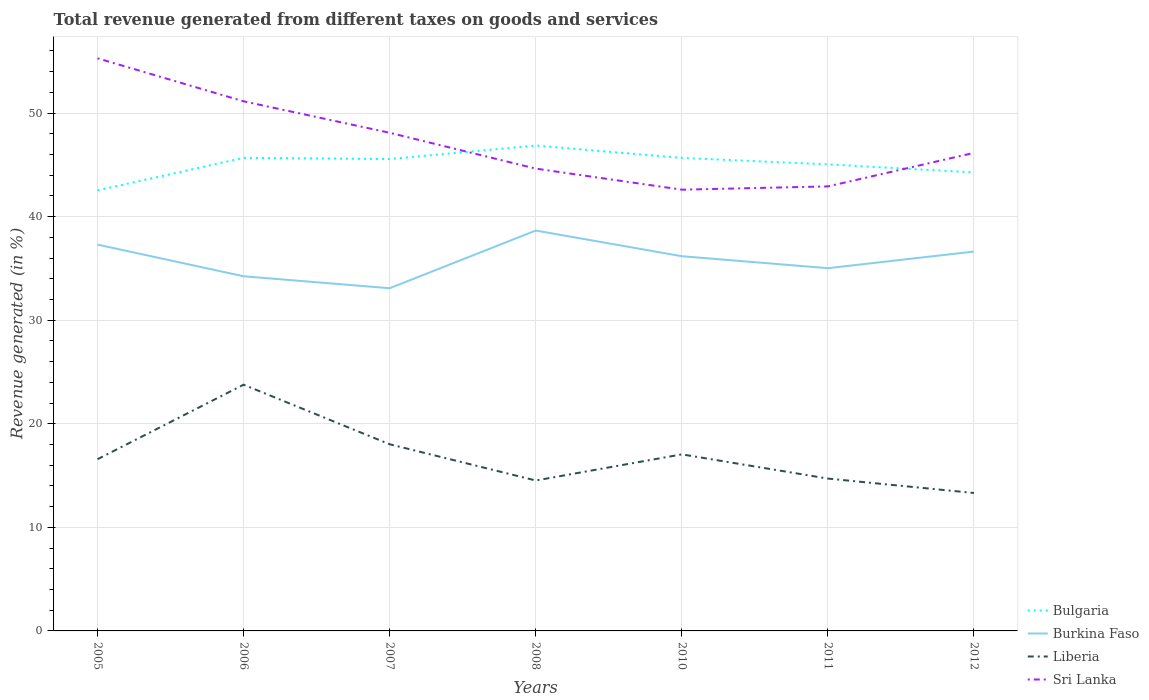How many different coloured lines are there?
Provide a short and direct response. 4. Does the line corresponding to Sri Lanka intersect with the line corresponding to Bulgaria?
Provide a short and direct response. Yes. Is the number of lines equal to the number of legend labels?
Give a very brief answer. Yes. Across all years, what is the maximum total revenue generated in Burkina Faso?
Provide a succinct answer. 33.08. In which year was the total revenue generated in Burkina Faso maximum?
Your response must be concise. 2007. What is the total total revenue generated in Sri Lanka in the graph?
Your response must be concise. -1.52. What is the difference between the highest and the second highest total revenue generated in Liberia?
Offer a terse response. 10.45. What is the difference between two consecutive major ticks on the Y-axis?
Your answer should be very brief. 10. Are the values on the major ticks of Y-axis written in scientific E-notation?
Your answer should be compact. No. Does the graph contain any zero values?
Give a very brief answer. No. Does the graph contain grids?
Offer a very short reply. Yes. How many legend labels are there?
Your response must be concise. 4. How are the legend labels stacked?
Your answer should be compact. Vertical. What is the title of the graph?
Make the answer very short. Total revenue generated from different taxes on goods and services. Does "Iraq" appear as one of the legend labels in the graph?
Offer a terse response. No. What is the label or title of the Y-axis?
Your answer should be very brief. Revenue generated (in %). What is the Revenue generated (in %) of Bulgaria in 2005?
Give a very brief answer. 42.54. What is the Revenue generated (in %) of Burkina Faso in 2005?
Ensure brevity in your answer.  37.3. What is the Revenue generated (in %) of Liberia in 2005?
Provide a succinct answer. 16.58. What is the Revenue generated (in %) in Sri Lanka in 2005?
Keep it short and to the point. 55.28. What is the Revenue generated (in %) in Bulgaria in 2006?
Your answer should be very brief. 45.67. What is the Revenue generated (in %) of Burkina Faso in 2006?
Offer a very short reply. 34.24. What is the Revenue generated (in %) in Liberia in 2006?
Your response must be concise. 23.77. What is the Revenue generated (in %) in Sri Lanka in 2006?
Make the answer very short. 51.13. What is the Revenue generated (in %) of Bulgaria in 2007?
Ensure brevity in your answer.  45.56. What is the Revenue generated (in %) in Burkina Faso in 2007?
Provide a succinct answer. 33.08. What is the Revenue generated (in %) of Liberia in 2007?
Give a very brief answer. 18.02. What is the Revenue generated (in %) of Sri Lanka in 2007?
Your answer should be very brief. 48.09. What is the Revenue generated (in %) in Bulgaria in 2008?
Make the answer very short. 46.86. What is the Revenue generated (in %) in Burkina Faso in 2008?
Provide a succinct answer. 38.66. What is the Revenue generated (in %) in Liberia in 2008?
Provide a succinct answer. 14.52. What is the Revenue generated (in %) of Sri Lanka in 2008?
Keep it short and to the point. 44.63. What is the Revenue generated (in %) in Bulgaria in 2010?
Keep it short and to the point. 45.67. What is the Revenue generated (in %) of Burkina Faso in 2010?
Offer a terse response. 36.18. What is the Revenue generated (in %) in Liberia in 2010?
Offer a terse response. 17.05. What is the Revenue generated (in %) of Sri Lanka in 2010?
Your response must be concise. 42.6. What is the Revenue generated (in %) in Bulgaria in 2011?
Offer a terse response. 45.04. What is the Revenue generated (in %) in Burkina Faso in 2011?
Keep it short and to the point. 35.02. What is the Revenue generated (in %) of Liberia in 2011?
Offer a terse response. 14.71. What is the Revenue generated (in %) of Sri Lanka in 2011?
Provide a short and direct response. 42.92. What is the Revenue generated (in %) in Bulgaria in 2012?
Ensure brevity in your answer.  44.27. What is the Revenue generated (in %) in Burkina Faso in 2012?
Your response must be concise. 36.63. What is the Revenue generated (in %) of Liberia in 2012?
Offer a very short reply. 13.32. What is the Revenue generated (in %) in Sri Lanka in 2012?
Give a very brief answer. 46.15. Across all years, what is the maximum Revenue generated (in %) in Bulgaria?
Keep it short and to the point. 46.86. Across all years, what is the maximum Revenue generated (in %) of Burkina Faso?
Your answer should be compact. 38.66. Across all years, what is the maximum Revenue generated (in %) in Liberia?
Give a very brief answer. 23.77. Across all years, what is the maximum Revenue generated (in %) in Sri Lanka?
Provide a short and direct response. 55.28. Across all years, what is the minimum Revenue generated (in %) of Bulgaria?
Your answer should be compact. 42.54. Across all years, what is the minimum Revenue generated (in %) of Burkina Faso?
Ensure brevity in your answer.  33.08. Across all years, what is the minimum Revenue generated (in %) of Liberia?
Ensure brevity in your answer.  13.32. Across all years, what is the minimum Revenue generated (in %) in Sri Lanka?
Offer a terse response. 42.6. What is the total Revenue generated (in %) in Bulgaria in the graph?
Make the answer very short. 315.61. What is the total Revenue generated (in %) of Burkina Faso in the graph?
Keep it short and to the point. 251.1. What is the total Revenue generated (in %) of Liberia in the graph?
Ensure brevity in your answer.  117.96. What is the total Revenue generated (in %) of Sri Lanka in the graph?
Give a very brief answer. 330.81. What is the difference between the Revenue generated (in %) in Bulgaria in 2005 and that in 2006?
Offer a terse response. -3.14. What is the difference between the Revenue generated (in %) in Burkina Faso in 2005 and that in 2006?
Provide a succinct answer. 3.06. What is the difference between the Revenue generated (in %) of Liberia in 2005 and that in 2006?
Make the answer very short. -7.19. What is the difference between the Revenue generated (in %) of Sri Lanka in 2005 and that in 2006?
Your answer should be compact. 4.15. What is the difference between the Revenue generated (in %) in Bulgaria in 2005 and that in 2007?
Your answer should be compact. -3.02. What is the difference between the Revenue generated (in %) in Burkina Faso in 2005 and that in 2007?
Ensure brevity in your answer.  4.21. What is the difference between the Revenue generated (in %) in Liberia in 2005 and that in 2007?
Your response must be concise. -1.44. What is the difference between the Revenue generated (in %) in Sri Lanka in 2005 and that in 2007?
Offer a terse response. 7.19. What is the difference between the Revenue generated (in %) of Bulgaria in 2005 and that in 2008?
Your answer should be compact. -4.33. What is the difference between the Revenue generated (in %) in Burkina Faso in 2005 and that in 2008?
Offer a terse response. -1.36. What is the difference between the Revenue generated (in %) of Liberia in 2005 and that in 2008?
Give a very brief answer. 2.06. What is the difference between the Revenue generated (in %) in Sri Lanka in 2005 and that in 2008?
Your answer should be compact. 10.65. What is the difference between the Revenue generated (in %) in Bulgaria in 2005 and that in 2010?
Make the answer very short. -3.13. What is the difference between the Revenue generated (in %) of Burkina Faso in 2005 and that in 2010?
Provide a short and direct response. 1.12. What is the difference between the Revenue generated (in %) in Liberia in 2005 and that in 2010?
Your answer should be very brief. -0.47. What is the difference between the Revenue generated (in %) in Sri Lanka in 2005 and that in 2010?
Provide a short and direct response. 12.68. What is the difference between the Revenue generated (in %) of Bulgaria in 2005 and that in 2011?
Ensure brevity in your answer.  -2.51. What is the difference between the Revenue generated (in %) in Burkina Faso in 2005 and that in 2011?
Provide a succinct answer. 2.28. What is the difference between the Revenue generated (in %) of Liberia in 2005 and that in 2011?
Give a very brief answer. 1.87. What is the difference between the Revenue generated (in %) of Sri Lanka in 2005 and that in 2011?
Offer a very short reply. 12.37. What is the difference between the Revenue generated (in %) of Bulgaria in 2005 and that in 2012?
Your answer should be very brief. -1.74. What is the difference between the Revenue generated (in %) in Burkina Faso in 2005 and that in 2012?
Your answer should be compact. 0.67. What is the difference between the Revenue generated (in %) in Liberia in 2005 and that in 2012?
Provide a short and direct response. 3.26. What is the difference between the Revenue generated (in %) in Sri Lanka in 2005 and that in 2012?
Give a very brief answer. 9.13. What is the difference between the Revenue generated (in %) in Bulgaria in 2006 and that in 2007?
Provide a succinct answer. 0.11. What is the difference between the Revenue generated (in %) in Burkina Faso in 2006 and that in 2007?
Your answer should be very brief. 1.16. What is the difference between the Revenue generated (in %) of Liberia in 2006 and that in 2007?
Your answer should be compact. 5.75. What is the difference between the Revenue generated (in %) of Sri Lanka in 2006 and that in 2007?
Make the answer very short. 3.04. What is the difference between the Revenue generated (in %) of Bulgaria in 2006 and that in 2008?
Your response must be concise. -1.19. What is the difference between the Revenue generated (in %) of Burkina Faso in 2006 and that in 2008?
Give a very brief answer. -4.42. What is the difference between the Revenue generated (in %) in Liberia in 2006 and that in 2008?
Provide a short and direct response. 9.25. What is the difference between the Revenue generated (in %) in Sri Lanka in 2006 and that in 2008?
Offer a terse response. 6.5. What is the difference between the Revenue generated (in %) in Bulgaria in 2006 and that in 2010?
Your response must be concise. 0.01. What is the difference between the Revenue generated (in %) in Burkina Faso in 2006 and that in 2010?
Give a very brief answer. -1.94. What is the difference between the Revenue generated (in %) in Liberia in 2006 and that in 2010?
Give a very brief answer. 6.73. What is the difference between the Revenue generated (in %) of Sri Lanka in 2006 and that in 2010?
Ensure brevity in your answer.  8.53. What is the difference between the Revenue generated (in %) in Bulgaria in 2006 and that in 2011?
Make the answer very short. 0.63. What is the difference between the Revenue generated (in %) in Burkina Faso in 2006 and that in 2011?
Your answer should be compact. -0.78. What is the difference between the Revenue generated (in %) of Liberia in 2006 and that in 2011?
Offer a very short reply. 9.06. What is the difference between the Revenue generated (in %) of Sri Lanka in 2006 and that in 2011?
Keep it short and to the point. 8.22. What is the difference between the Revenue generated (in %) of Bulgaria in 2006 and that in 2012?
Your answer should be very brief. 1.4. What is the difference between the Revenue generated (in %) of Burkina Faso in 2006 and that in 2012?
Your answer should be compact. -2.39. What is the difference between the Revenue generated (in %) of Liberia in 2006 and that in 2012?
Keep it short and to the point. 10.45. What is the difference between the Revenue generated (in %) of Sri Lanka in 2006 and that in 2012?
Provide a succinct answer. 4.98. What is the difference between the Revenue generated (in %) in Bulgaria in 2007 and that in 2008?
Provide a short and direct response. -1.3. What is the difference between the Revenue generated (in %) of Burkina Faso in 2007 and that in 2008?
Your answer should be compact. -5.57. What is the difference between the Revenue generated (in %) of Liberia in 2007 and that in 2008?
Offer a terse response. 3.5. What is the difference between the Revenue generated (in %) in Sri Lanka in 2007 and that in 2008?
Make the answer very short. 3.46. What is the difference between the Revenue generated (in %) in Bulgaria in 2007 and that in 2010?
Provide a succinct answer. -0.11. What is the difference between the Revenue generated (in %) of Burkina Faso in 2007 and that in 2010?
Provide a succinct answer. -3.09. What is the difference between the Revenue generated (in %) of Liberia in 2007 and that in 2010?
Provide a short and direct response. 0.97. What is the difference between the Revenue generated (in %) in Sri Lanka in 2007 and that in 2010?
Provide a short and direct response. 5.49. What is the difference between the Revenue generated (in %) of Bulgaria in 2007 and that in 2011?
Your response must be concise. 0.52. What is the difference between the Revenue generated (in %) of Burkina Faso in 2007 and that in 2011?
Your response must be concise. -1.94. What is the difference between the Revenue generated (in %) in Liberia in 2007 and that in 2011?
Give a very brief answer. 3.31. What is the difference between the Revenue generated (in %) in Sri Lanka in 2007 and that in 2011?
Provide a succinct answer. 5.18. What is the difference between the Revenue generated (in %) in Bulgaria in 2007 and that in 2012?
Keep it short and to the point. 1.29. What is the difference between the Revenue generated (in %) of Burkina Faso in 2007 and that in 2012?
Provide a succinct answer. -3.54. What is the difference between the Revenue generated (in %) in Liberia in 2007 and that in 2012?
Provide a short and direct response. 4.7. What is the difference between the Revenue generated (in %) in Sri Lanka in 2007 and that in 2012?
Your answer should be very brief. 1.94. What is the difference between the Revenue generated (in %) in Bulgaria in 2008 and that in 2010?
Your answer should be compact. 1.2. What is the difference between the Revenue generated (in %) of Burkina Faso in 2008 and that in 2010?
Provide a short and direct response. 2.48. What is the difference between the Revenue generated (in %) of Liberia in 2008 and that in 2010?
Offer a very short reply. -2.52. What is the difference between the Revenue generated (in %) of Sri Lanka in 2008 and that in 2010?
Your answer should be very brief. 2.03. What is the difference between the Revenue generated (in %) of Bulgaria in 2008 and that in 2011?
Make the answer very short. 1.82. What is the difference between the Revenue generated (in %) in Burkina Faso in 2008 and that in 2011?
Offer a very short reply. 3.63. What is the difference between the Revenue generated (in %) of Liberia in 2008 and that in 2011?
Give a very brief answer. -0.19. What is the difference between the Revenue generated (in %) of Sri Lanka in 2008 and that in 2011?
Provide a short and direct response. 1.72. What is the difference between the Revenue generated (in %) in Bulgaria in 2008 and that in 2012?
Give a very brief answer. 2.59. What is the difference between the Revenue generated (in %) in Burkina Faso in 2008 and that in 2012?
Your answer should be compact. 2.03. What is the difference between the Revenue generated (in %) in Liberia in 2008 and that in 2012?
Offer a terse response. 1.21. What is the difference between the Revenue generated (in %) of Sri Lanka in 2008 and that in 2012?
Provide a succinct answer. -1.52. What is the difference between the Revenue generated (in %) of Bulgaria in 2010 and that in 2011?
Your answer should be compact. 0.62. What is the difference between the Revenue generated (in %) of Burkina Faso in 2010 and that in 2011?
Ensure brevity in your answer.  1.16. What is the difference between the Revenue generated (in %) of Liberia in 2010 and that in 2011?
Your answer should be very brief. 2.34. What is the difference between the Revenue generated (in %) in Sri Lanka in 2010 and that in 2011?
Make the answer very short. -0.32. What is the difference between the Revenue generated (in %) of Bulgaria in 2010 and that in 2012?
Your answer should be very brief. 1.4. What is the difference between the Revenue generated (in %) of Burkina Faso in 2010 and that in 2012?
Your answer should be very brief. -0.45. What is the difference between the Revenue generated (in %) of Liberia in 2010 and that in 2012?
Offer a terse response. 3.73. What is the difference between the Revenue generated (in %) of Sri Lanka in 2010 and that in 2012?
Give a very brief answer. -3.55. What is the difference between the Revenue generated (in %) in Bulgaria in 2011 and that in 2012?
Make the answer very short. 0.77. What is the difference between the Revenue generated (in %) in Burkina Faso in 2011 and that in 2012?
Provide a short and direct response. -1.61. What is the difference between the Revenue generated (in %) of Liberia in 2011 and that in 2012?
Your answer should be compact. 1.39. What is the difference between the Revenue generated (in %) of Sri Lanka in 2011 and that in 2012?
Your answer should be very brief. -3.24. What is the difference between the Revenue generated (in %) of Bulgaria in 2005 and the Revenue generated (in %) of Burkina Faso in 2006?
Ensure brevity in your answer.  8.3. What is the difference between the Revenue generated (in %) in Bulgaria in 2005 and the Revenue generated (in %) in Liberia in 2006?
Offer a very short reply. 18.76. What is the difference between the Revenue generated (in %) in Bulgaria in 2005 and the Revenue generated (in %) in Sri Lanka in 2006?
Your response must be concise. -8.6. What is the difference between the Revenue generated (in %) of Burkina Faso in 2005 and the Revenue generated (in %) of Liberia in 2006?
Ensure brevity in your answer.  13.52. What is the difference between the Revenue generated (in %) in Burkina Faso in 2005 and the Revenue generated (in %) in Sri Lanka in 2006?
Give a very brief answer. -13.84. What is the difference between the Revenue generated (in %) of Liberia in 2005 and the Revenue generated (in %) of Sri Lanka in 2006?
Keep it short and to the point. -34.55. What is the difference between the Revenue generated (in %) of Bulgaria in 2005 and the Revenue generated (in %) of Burkina Faso in 2007?
Make the answer very short. 9.45. What is the difference between the Revenue generated (in %) of Bulgaria in 2005 and the Revenue generated (in %) of Liberia in 2007?
Offer a very short reply. 24.52. What is the difference between the Revenue generated (in %) in Bulgaria in 2005 and the Revenue generated (in %) in Sri Lanka in 2007?
Make the answer very short. -5.56. What is the difference between the Revenue generated (in %) of Burkina Faso in 2005 and the Revenue generated (in %) of Liberia in 2007?
Give a very brief answer. 19.28. What is the difference between the Revenue generated (in %) of Burkina Faso in 2005 and the Revenue generated (in %) of Sri Lanka in 2007?
Your response must be concise. -10.8. What is the difference between the Revenue generated (in %) of Liberia in 2005 and the Revenue generated (in %) of Sri Lanka in 2007?
Make the answer very short. -31.51. What is the difference between the Revenue generated (in %) of Bulgaria in 2005 and the Revenue generated (in %) of Burkina Faso in 2008?
Give a very brief answer. 3.88. What is the difference between the Revenue generated (in %) of Bulgaria in 2005 and the Revenue generated (in %) of Liberia in 2008?
Your response must be concise. 28.01. What is the difference between the Revenue generated (in %) of Bulgaria in 2005 and the Revenue generated (in %) of Sri Lanka in 2008?
Ensure brevity in your answer.  -2.1. What is the difference between the Revenue generated (in %) in Burkina Faso in 2005 and the Revenue generated (in %) in Liberia in 2008?
Provide a succinct answer. 22.77. What is the difference between the Revenue generated (in %) of Burkina Faso in 2005 and the Revenue generated (in %) of Sri Lanka in 2008?
Give a very brief answer. -7.34. What is the difference between the Revenue generated (in %) in Liberia in 2005 and the Revenue generated (in %) in Sri Lanka in 2008?
Provide a succinct answer. -28.06. What is the difference between the Revenue generated (in %) in Bulgaria in 2005 and the Revenue generated (in %) in Burkina Faso in 2010?
Ensure brevity in your answer.  6.36. What is the difference between the Revenue generated (in %) in Bulgaria in 2005 and the Revenue generated (in %) in Liberia in 2010?
Make the answer very short. 25.49. What is the difference between the Revenue generated (in %) in Bulgaria in 2005 and the Revenue generated (in %) in Sri Lanka in 2010?
Your answer should be compact. -0.06. What is the difference between the Revenue generated (in %) in Burkina Faso in 2005 and the Revenue generated (in %) in Liberia in 2010?
Provide a succinct answer. 20.25. What is the difference between the Revenue generated (in %) of Burkina Faso in 2005 and the Revenue generated (in %) of Sri Lanka in 2010?
Make the answer very short. -5.3. What is the difference between the Revenue generated (in %) of Liberia in 2005 and the Revenue generated (in %) of Sri Lanka in 2010?
Provide a short and direct response. -26.02. What is the difference between the Revenue generated (in %) in Bulgaria in 2005 and the Revenue generated (in %) in Burkina Faso in 2011?
Your answer should be compact. 7.52. What is the difference between the Revenue generated (in %) of Bulgaria in 2005 and the Revenue generated (in %) of Liberia in 2011?
Give a very brief answer. 27.83. What is the difference between the Revenue generated (in %) of Bulgaria in 2005 and the Revenue generated (in %) of Sri Lanka in 2011?
Provide a short and direct response. -0.38. What is the difference between the Revenue generated (in %) of Burkina Faso in 2005 and the Revenue generated (in %) of Liberia in 2011?
Offer a terse response. 22.59. What is the difference between the Revenue generated (in %) of Burkina Faso in 2005 and the Revenue generated (in %) of Sri Lanka in 2011?
Your answer should be very brief. -5.62. What is the difference between the Revenue generated (in %) of Liberia in 2005 and the Revenue generated (in %) of Sri Lanka in 2011?
Offer a very short reply. -26.34. What is the difference between the Revenue generated (in %) in Bulgaria in 2005 and the Revenue generated (in %) in Burkina Faso in 2012?
Your answer should be compact. 5.91. What is the difference between the Revenue generated (in %) in Bulgaria in 2005 and the Revenue generated (in %) in Liberia in 2012?
Keep it short and to the point. 29.22. What is the difference between the Revenue generated (in %) in Bulgaria in 2005 and the Revenue generated (in %) in Sri Lanka in 2012?
Ensure brevity in your answer.  -3.62. What is the difference between the Revenue generated (in %) in Burkina Faso in 2005 and the Revenue generated (in %) in Liberia in 2012?
Your answer should be compact. 23.98. What is the difference between the Revenue generated (in %) in Burkina Faso in 2005 and the Revenue generated (in %) in Sri Lanka in 2012?
Give a very brief answer. -8.86. What is the difference between the Revenue generated (in %) of Liberia in 2005 and the Revenue generated (in %) of Sri Lanka in 2012?
Your answer should be compact. -29.57. What is the difference between the Revenue generated (in %) of Bulgaria in 2006 and the Revenue generated (in %) of Burkina Faso in 2007?
Keep it short and to the point. 12.59. What is the difference between the Revenue generated (in %) of Bulgaria in 2006 and the Revenue generated (in %) of Liberia in 2007?
Your response must be concise. 27.65. What is the difference between the Revenue generated (in %) of Bulgaria in 2006 and the Revenue generated (in %) of Sri Lanka in 2007?
Provide a short and direct response. -2.42. What is the difference between the Revenue generated (in %) in Burkina Faso in 2006 and the Revenue generated (in %) in Liberia in 2007?
Provide a succinct answer. 16.22. What is the difference between the Revenue generated (in %) in Burkina Faso in 2006 and the Revenue generated (in %) in Sri Lanka in 2007?
Give a very brief answer. -13.85. What is the difference between the Revenue generated (in %) of Liberia in 2006 and the Revenue generated (in %) of Sri Lanka in 2007?
Offer a very short reply. -24.32. What is the difference between the Revenue generated (in %) in Bulgaria in 2006 and the Revenue generated (in %) in Burkina Faso in 2008?
Give a very brief answer. 7.02. What is the difference between the Revenue generated (in %) of Bulgaria in 2006 and the Revenue generated (in %) of Liberia in 2008?
Give a very brief answer. 31.15. What is the difference between the Revenue generated (in %) of Bulgaria in 2006 and the Revenue generated (in %) of Sri Lanka in 2008?
Your response must be concise. 1.04. What is the difference between the Revenue generated (in %) of Burkina Faso in 2006 and the Revenue generated (in %) of Liberia in 2008?
Give a very brief answer. 19.72. What is the difference between the Revenue generated (in %) in Burkina Faso in 2006 and the Revenue generated (in %) in Sri Lanka in 2008?
Your response must be concise. -10.39. What is the difference between the Revenue generated (in %) of Liberia in 2006 and the Revenue generated (in %) of Sri Lanka in 2008?
Provide a succinct answer. -20.86. What is the difference between the Revenue generated (in %) in Bulgaria in 2006 and the Revenue generated (in %) in Burkina Faso in 2010?
Provide a short and direct response. 9.5. What is the difference between the Revenue generated (in %) in Bulgaria in 2006 and the Revenue generated (in %) in Liberia in 2010?
Give a very brief answer. 28.63. What is the difference between the Revenue generated (in %) of Bulgaria in 2006 and the Revenue generated (in %) of Sri Lanka in 2010?
Make the answer very short. 3.07. What is the difference between the Revenue generated (in %) of Burkina Faso in 2006 and the Revenue generated (in %) of Liberia in 2010?
Offer a very short reply. 17.19. What is the difference between the Revenue generated (in %) in Burkina Faso in 2006 and the Revenue generated (in %) in Sri Lanka in 2010?
Provide a short and direct response. -8.36. What is the difference between the Revenue generated (in %) of Liberia in 2006 and the Revenue generated (in %) of Sri Lanka in 2010?
Your answer should be compact. -18.83. What is the difference between the Revenue generated (in %) of Bulgaria in 2006 and the Revenue generated (in %) of Burkina Faso in 2011?
Offer a terse response. 10.65. What is the difference between the Revenue generated (in %) of Bulgaria in 2006 and the Revenue generated (in %) of Liberia in 2011?
Provide a succinct answer. 30.97. What is the difference between the Revenue generated (in %) in Bulgaria in 2006 and the Revenue generated (in %) in Sri Lanka in 2011?
Provide a short and direct response. 2.76. What is the difference between the Revenue generated (in %) in Burkina Faso in 2006 and the Revenue generated (in %) in Liberia in 2011?
Make the answer very short. 19.53. What is the difference between the Revenue generated (in %) of Burkina Faso in 2006 and the Revenue generated (in %) of Sri Lanka in 2011?
Provide a succinct answer. -8.68. What is the difference between the Revenue generated (in %) in Liberia in 2006 and the Revenue generated (in %) in Sri Lanka in 2011?
Your response must be concise. -19.14. What is the difference between the Revenue generated (in %) of Bulgaria in 2006 and the Revenue generated (in %) of Burkina Faso in 2012?
Your response must be concise. 9.05. What is the difference between the Revenue generated (in %) in Bulgaria in 2006 and the Revenue generated (in %) in Liberia in 2012?
Keep it short and to the point. 32.36. What is the difference between the Revenue generated (in %) of Bulgaria in 2006 and the Revenue generated (in %) of Sri Lanka in 2012?
Offer a terse response. -0.48. What is the difference between the Revenue generated (in %) of Burkina Faso in 2006 and the Revenue generated (in %) of Liberia in 2012?
Your response must be concise. 20.92. What is the difference between the Revenue generated (in %) of Burkina Faso in 2006 and the Revenue generated (in %) of Sri Lanka in 2012?
Offer a very short reply. -11.91. What is the difference between the Revenue generated (in %) in Liberia in 2006 and the Revenue generated (in %) in Sri Lanka in 2012?
Keep it short and to the point. -22.38. What is the difference between the Revenue generated (in %) in Bulgaria in 2007 and the Revenue generated (in %) in Burkina Faso in 2008?
Make the answer very short. 6.9. What is the difference between the Revenue generated (in %) of Bulgaria in 2007 and the Revenue generated (in %) of Liberia in 2008?
Your answer should be compact. 31.04. What is the difference between the Revenue generated (in %) of Bulgaria in 2007 and the Revenue generated (in %) of Sri Lanka in 2008?
Your answer should be compact. 0.92. What is the difference between the Revenue generated (in %) in Burkina Faso in 2007 and the Revenue generated (in %) in Liberia in 2008?
Provide a succinct answer. 18.56. What is the difference between the Revenue generated (in %) in Burkina Faso in 2007 and the Revenue generated (in %) in Sri Lanka in 2008?
Offer a very short reply. -11.55. What is the difference between the Revenue generated (in %) in Liberia in 2007 and the Revenue generated (in %) in Sri Lanka in 2008?
Give a very brief answer. -26.61. What is the difference between the Revenue generated (in %) in Bulgaria in 2007 and the Revenue generated (in %) in Burkina Faso in 2010?
Your answer should be very brief. 9.38. What is the difference between the Revenue generated (in %) of Bulgaria in 2007 and the Revenue generated (in %) of Liberia in 2010?
Offer a terse response. 28.51. What is the difference between the Revenue generated (in %) in Bulgaria in 2007 and the Revenue generated (in %) in Sri Lanka in 2010?
Give a very brief answer. 2.96. What is the difference between the Revenue generated (in %) in Burkina Faso in 2007 and the Revenue generated (in %) in Liberia in 2010?
Keep it short and to the point. 16.04. What is the difference between the Revenue generated (in %) in Burkina Faso in 2007 and the Revenue generated (in %) in Sri Lanka in 2010?
Provide a succinct answer. -9.52. What is the difference between the Revenue generated (in %) in Liberia in 2007 and the Revenue generated (in %) in Sri Lanka in 2010?
Provide a succinct answer. -24.58. What is the difference between the Revenue generated (in %) of Bulgaria in 2007 and the Revenue generated (in %) of Burkina Faso in 2011?
Offer a very short reply. 10.54. What is the difference between the Revenue generated (in %) of Bulgaria in 2007 and the Revenue generated (in %) of Liberia in 2011?
Make the answer very short. 30.85. What is the difference between the Revenue generated (in %) in Bulgaria in 2007 and the Revenue generated (in %) in Sri Lanka in 2011?
Offer a very short reply. 2.64. What is the difference between the Revenue generated (in %) in Burkina Faso in 2007 and the Revenue generated (in %) in Liberia in 2011?
Provide a short and direct response. 18.38. What is the difference between the Revenue generated (in %) of Burkina Faso in 2007 and the Revenue generated (in %) of Sri Lanka in 2011?
Offer a very short reply. -9.83. What is the difference between the Revenue generated (in %) in Liberia in 2007 and the Revenue generated (in %) in Sri Lanka in 2011?
Provide a short and direct response. -24.9. What is the difference between the Revenue generated (in %) of Bulgaria in 2007 and the Revenue generated (in %) of Burkina Faso in 2012?
Provide a succinct answer. 8.93. What is the difference between the Revenue generated (in %) of Bulgaria in 2007 and the Revenue generated (in %) of Liberia in 2012?
Provide a succinct answer. 32.24. What is the difference between the Revenue generated (in %) in Bulgaria in 2007 and the Revenue generated (in %) in Sri Lanka in 2012?
Make the answer very short. -0.59. What is the difference between the Revenue generated (in %) in Burkina Faso in 2007 and the Revenue generated (in %) in Liberia in 2012?
Keep it short and to the point. 19.77. What is the difference between the Revenue generated (in %) in Burkina Faso in 2007 and the Revenue generated (in %) in Sri Lanka in 2012?
Provide a short and direct response. -13.07. What is the difference between the Revenue generated (in %) of Liberia in 2007 and the Revenue generated (in %) of Sri Lanka in 2012?
Provide a succinct answer. -28.13. What is the difference between the Revenue generated (in %) of Bulgaria in 2008 and the Revenue generated (in %) of Burkina Faso in 2010?
Offer a very short reply. 10.69. What is the difference between the Revenue generated (in %) of Bulgaria in 2008 and the Revenue generated (in %) of Liberia in 2010?
Offer a terse response. 29.82. What is the difference between the Revenue generated (in %) of Bulgaria in 2008 and the Revenue generated (in %) of Sri Lanka in 2010?
Offer a very short reply. 4.26. What is the difference between the Revenue generated (in %) of Burkina Faso in 2008 and the Revenue generated (in %) of Liberia in 2010?
Your response must be concise. 21.61. What is the difference between the Revenue generated (in %) in Burkina Faso in 2008 and the Revenue generated (in %) in Sri Lanka in 2010?
Provide a short and direct response. -3.94. What is the difference between the Revenue generated (in %) in Liberia in 2008 and the Revenue generated (in %) in Sri Lanka in 2010?
Make the answer very short. -28.08. What is the difference between the Revenue generated (in %) of Bulgaria in 2008 and the Revenue generated (in %) of Burkina Faso in 2011?
Give a very brief answer. 11.84. What is the difference between the Revenue generated (in %) in Bulgaria in 2008 and the Revenue generated (in %) in Liberia in 2011?
Offer a terse response. 32.15. What is the difference between the Revenue generated (in %) in Bulgaria in 2008 and the Revenue generated (in %) in Sri Lanka in 2011?
Your response must be concise. 3.95. What is the difference between the Revenue generated (in %) of Burkina Faso in 2008 and the Revenue generated (in %) of Liberia in 2011?
Give a very brief answer. 23.95. What is the difference between the Revenue generated (in %) in Burkina Faso in 2008 and the Revenue generated (in %) in Sri Lanka in 2011?
Your answer should be very brief. -4.26. What is the difference between the Revenue generated (in %) in Liberia in 2008 and the Revenue generated (in %) in Sri Lanka in 2011?
Give a very brief answer. -28.39. What is the difference between the Revenue generated (in %) in Bulgaria in 2008 and the Revenue generated (in %) in Burkina Faso in 2012?
Your answer should be very brief. 10.24. What is the difference between the Revenue generated (in %) in Bulgaria in 2008 and the Revenue generated (in %) in Liberia in 2012?
Your answer should be compact. 33.55. What is the difference between the Revenue generated (in %) in Bulgaria in 2008 and the Revenue generated (in %) in Sri Lanka in 2012?
Your answer should be very brief. 0.71. What is the difference between the Revenue generated (in %) of Burkina Faso in 2008 and the Revenue generated (in %) of Liberia in 2012?
Provide a succinct answer. 25.34. What is the difference between the Revenue generated (in %) of Burkina Faso in 2008 and the Revenue generated (in %) of Sri Lanka in 2012?
Keep it short and to the point. -7.5. What is the difference between the Revenue generated (in %) of Liberia in 2008 and the Revenue generated (in %) of Sri Lanka in 2012?
Your response must be concise. -31.63. What is the difference between the Revenue generated (in %) of Bulgaria in 2010 and the Revenue generated (in %) of Burkina Faso in 2011?
Offer a terse response. 10.65. What is the difference between the Revenue generated (in %) of Bulgaria in 2010 and the Revenue generated (in %) of Liberia in 2011?
Your answer should be very brief. 30.96. What is the difference between the Revenue generated (in %) in Bulgaria in 2010 and the Revenue generated (in %) in Sri Lanka in 2011?
Give a very brief answer. 2.75. What is the difference between the Revenue generated (in %) in Burkina Faso in 2010 and the Revenue generated (in %) in Liberia in 2011?
Offer a terse response. 21.47. What is the difference between the Revenue generated (in %) of Burkina Faso in 2010 and the Revenue generated (in %) of Sri Lanka in 2011?
Provide a short and direct response. -6.74. What is the difference between the Revenue generated (in %) in Liberia in 2010 and the Revenue generated (in %) in Sri Lanka in 2011?
Provide a succinct answer. -25.87. What is the difference between the Revenue generated (in %) in Bulgaria in 2010 and the Revenue generated (in %) in Burkina Faso in 2012?
Give a very brief answer. 9.04. What is the difference between the Revenue generated (in %) in Bulgaria in 2010 and the Revenue generated (in %) in Liberia in 2012?
Offer a very short reply. 32.35. What is the difference between the Revenue generated (in %) of Bulgaria in 2010 and the Revenue generated (in %) of Sri Lanka in 2012?
Provide a short and direct response. -0.49. What is the difference between the Revenue generated (in %) in Burkina Faso in 2010 and the Revenue generated (in %) in Liberia in 2012?
Provide a succinct answer. 22.86. What is the difference between the Revenue generated (in %) of Burkina Faso in 2010 and the Revenue generated (in %) of Sri Lanka in 2012?
Provide a short and direct response. -9.97. What is the difference between the Revenue generated (in %) in Liberia in 2010 and the Revenue generated (in %) in Sri Lanka in 2012?
Give a very brief answer. -29.11. What is the difference between the Revenue generated (in %) in Bulgaria in 2011 and the Revenue generated (in %) in Burkina Faso in 2012?
Provide a succinct answer. 8.42. What is the difference between the Revenue generated (in %) of Bulgaria in 2011 and the Revenue generated (in %) of Liberia in 2012?
Offer a terse response. 31.73. What is the difference between the Revenue generated (in %) of Bulgaria in 2011 and the Revenue generated (in %) of Sri Lanka in 2012?
Your answer should be very brief. -1.11. What is the difference between the Revenue generated (in %) in Burkina Faso in 2011 and the Revenue generated (in %) in Liberia in 2012?
Keep it short and to the point. 21.7. What is the difference between the Revenue generated (in %) of Burkina Faso in 2011 and the Revenue generated (in %) of Sri Lanka in 2012?
Give a very brief answer. -11.13. What is the difference between the Revenue generated (in %) in Liberia in 2011 and the Revenue generated (in %) in Sri Lanka in 2012?
Keep it short and to the point. -31.44. What is the average Revenue generated (in %) of Bulgaria per year?
Your response must be concise. 45.09. What is the average Revenue generated (in %) of Burkina Faso per year?
Your response must be concise. 35.87. What is the average Revenue generated (in %) in Liberia per year?
Offer a terse response. 16.85. What is the average Revenue generated (in %) of Sri Lanka per year?
Keep it short and to the point. 47.26. In the year 2005, what is the difference between the Revenue generated (in %) of Bulgaria and Revenue generated (in %) of Burkina Faso?
Keep it short and to the point. 5.24. In the year 2005, what is the difference between the Revenue generated (in %) in Bulgaria and Revenue generated (in %) in Liberia?
Offer a very short reply. 25.96. In the year 2005, what is the difference between the Revenue generated (in %) of Bulgaria and Revenue generated (in %) of Sri Lanka?
Your answer should be compact. -12.75. In the year 2005, what is the difference between the Revenue generated (in %) of Burkina Faso and Revenue generated (in %) of Liberia?
Your answer should be very brief. 20.72. In the year 2005, what is the difference between the Revenue generated (in %) in Burkina Faso and Revenue generated (in %) in Sri Lanka?
Provide a succinct answer. -17.99. In the year 2005, what is the difference between the Revenue generated (in %) in Liberia and Revenue generated (in %) in Sri Lanka?
Provide a short and direct response. -38.7. In the year 2006, what is the difference between the Revenue generated (in %) of Bulgaria and Revenue generated (in %) of Burkina Faso?
Offer a terse response. 11.43. In the year 2006, what is the difference between the Revenue generated (in %) of Bulgaria and Revenue generated (in %) of Liberia?
Your response must be concise. 21.9. In the year 2006, what is the difference between the Revenue generated (in %) of Bulgaria and Revenue generated (in %) of Sri Lanka?
Your response must be concise. -5.46. In the year 2006, what is the difference between the Revenue generated (in %) of Burkina Faso and Revenue generated (in %) of Liberia?
Your response must be concise. 10.47. In the year 2006, what is the difference between the Revenue generated (in %) of Burkina Faso and Revenue generated (in %) of Sri Lanka?
Provide a short and direct response. -16.89. In the year 2006, what is the difference between the Revenue generated (in %) in Liberia and Revenue generated (in %) in Sri Lanka?
Provide a short and direct response. -27.36. In the year 2007, what is the difference between the Revenue generated (in %) in Bulgaria and Revenue generated (in %) in Burkina Faso?
Your response must be concise. 12.47. In the year 2007, what is the difference between the Revenue generated (in %) of Bulgaria and Revenue generated (in %) of Liberia?
Your answer should be compact. 27.54. In the year 2007, what is the difference between the Revenue generated (in %) of Bulgaria and Revenue generated (in %) of Sri Lanka?
Ensure brevity in your answer.  -2.53. In the year 2007, what is the difference between the Revenue generated (in %) in Burkina Faso and Revenue generated (in %) in Liberia?
Your response must be concise. 15.06. In the year 2007, what is the difference between the Revenue generated (in %) in Burkina Faso and Revenue generated (in %) in Sri Lanka?
Keep it short and to the point. -15.01. In the year 2007, what is the difference between the Revenue generated (in %) of Liberia and Revenue generated (in %) of Sri Lanka?
Provide a short and direct response. -30.07. In the year 2008, what is the difference between the Revenue generated (in %) in Bulgaria and Revenue generated (in %) in Burkina Faso?
Provide a short and direct response. 8.21. In the year 2008, what is the difference between the Revenue generated (in %) of Bulgaria and Revenue generated (in %) of Liberia?
Your answer should be very brief. 32.34. In the year 2008, what is the difference between the Revenue generated (in %) of Bulgaria and Revenue generated (in %) of Sri Lanka?
Keep it short and to the point. 2.23. In the year 2008, what is the difference between the Revenue generated (in %) in Burkina Faso and Revenue generated (in %) in Liberia?
Give a very brief answer. 24.13. In the year 2008, what is the difference between the Revenue generated (in %) of Burkina Faso and Revenue generated (in %) of Sri Lanka?
Provide a short and direct response. -5.98. In the year 2008, what is the difference between the Revenue generated (in %) in Liberia and Revenue generated (in %) in Sri Lanka?
Offer a very short reply. -30.11. In the year 2010, what is the difference between the Revenue generated (in %) of Bulgaria and Revenue generated (in %) of Burkina Faso?
Ensure brevity in your answer.  9.49. In the year 2010, what is the difference between the Revenue generated (in %) of Bulgaria and Revenue generated (in %) of Liberia?
Your answer should be very brief. 28.62. In the year 2010, what is the difference between the Revenue generated (in %) in Bulgaria and Revenue generated (in %) in Sri Lanka?
Offer a very short reply. 3.07. In the year 2010, what is the difference between the Revenue generated (in %) in Burkina Faso and Revenue generated (in %) in Liberia?
Your answer should be very brief. 19.13. In the year 2010, what is the difference between the Revenue generated (in %) in Burkina Faso and Revenue generated (in %) in Sri Lanka?
Your response must be concise. -6.42. In the year 2010, what is the difference between the Revenue generated (in %) in Liberia and Revenue generated (in %) in Sri Lanka?
Ensure brevity in your answer.  -25.55. In the year 2011, what is the difference between the Revenue generated (in %) in Bulgaria and Revenue generated (in %) in Burkina Faso?
Keep it short and to the point. 10.02. In the year 2011, what is the difference between the Revenue generated (in %) of Bulgaria and Revenue generated (in %) of Liberia?
Provide a short and direct response. 30.33. In the year 2011, what is the difference between the Revenue generated (in %) in Bulgaria and Revenue generated (in %) in Sri Lanka?
Your answer should be very brief. 2.13. In the year 2011, what is the difference between the Revenue generated (in %) in Burkina Faso and Revenue generated (in %) in Liberia?
Provide a succinct answer. 20.31. In the year 2011, what is the difference between the Revenue generated (in %) in Burkina Faso and Revenue generated (in %) in Sri Lanka?
Offer a very short reply. -7.9. In the year 2011, what is the difference between the Revenue generated (in %) of Liberia and Revenue generated (in %) of Sri Lanka?
Offer a terse response. -28.21. In the year 2012, what is the difference between the Revenue generated (in %) of Bulgaria and Revenue generated (in %) of Burkina Faso?
Your answer should be compact. 7.64. In the year 2012, what is the difference between the Revenue generated (in %) of Bulgaria and Revenue generated (in %) of Liberia?
Ensure brevity in your answer.  30.95. In the year 2012, what is the difference between the Revenue generated (in %) of Bulgaria and Revenue generated (in %) of Sri Lanka?
Provide a short and direct response. -1.88. In the year 2012, what is the difference between the Revenue generated (in %) in Burkina Faso and Revenue generated (in %) in Liberia?
Give a very brief answer. 23.31. In the year 2012, what is the difference between the Revenue generated (in %) of Burkina Faso and Revenue generated (in %) of Sri Lanka?
Your answer should be very brief. -9.53. In the year 2012, what is the difference between the Revenue generated (in %) of Liberia and Revenue generated (in %) of Sri Lanka?
Make the answer very short. -32.84. What is the ratio of the Revenue generated (in %) in Bulgaria in 2005 to that in 2006?
Give a very brief answer. 0.93. What is the ratio of the Revenue generated (in %) of Burkina Faso in 2005 to that in 2006?
Offer a terse response. 1.09. What is the ratio of the Revenue generated (in %) in Liberia in 2005 to that in 2006?
Ensure brevity in your answer.  0.7. What is the ratio of the Revenue generated (in %) of Sri Lanka in 2005 to that in 2006?
Your answer should be very brief. 1.08. What is the ratio of the Revenue generated (in %) in Bulgaria in 2005 to that in 2007?
Your answer should be very brief. 0.93. What is the ratio of the Revenue generated (in %) of Burkina Faso in 2005 to that in 2007?
Your answer should be compact. 1.13. What is the ratio of the Revenue generated (in %) in Liberia in 2005 to that in 2007?
Keep it short and to the point. 0.92. What is the ratio of the Revenue generated (in %) of Sri Lanka in 2005 to that in 2007?
Offer a terse response. 1.15. What is the ratio of the Revenue generated (in %) in Bulgaria in 2005 to that in 2008?
Offer a terse response. 0.91. What is the ratio of the Revenue generated (in %) of Burkina Faso in 2005 to that in 2008?
Keep it short and to the point. 0.96. What is the ratio of the Revenue generated (in %) in Liberia in 2005 to that in 2008?
Provide a succinct answer. 1.14. What is the ratio of the Revenue generated (in %) in Sri Lanka in 2005 to that in 2008?
Offer a terse response. 1.24. What is the ratio of the Revenue generated (in %) in Bulgaria in 2005 to that in 2010?
Keep it short and to the point. 0.93. What is the ratio of the Revenue generated (in %) of Burkina Faso in 2005 to that in 2010?
Your answer should be very brief. 1.03. What is the ratio of the Revenue generated (in %) in Liberia in 2005 to that in 2010?
Offer a very short reply. 0.97. What is the ratio of the Revenue generated (in %) of Sri Lanka in 2005 to that in 2010?
Your answer should be compact. 1.3. What is the ratio of the Revenue generated (in %) of Bulgaria in 2005 to that in 2011?
Give a very brief answer. 0.94. What is the ratio of the Revenue generated (in %) of Burkina Faso in 2005 to that in 2011?
Give a very brief answer. 1.06. What is the ratio of the Revenue generated (in %) of Liberia in 2005 to that in 2011?
Your response must be concise. 1.13. What is the ratio of the Revenue generated (in %) in Sri Lanka in 2005 to that in 2011?
Give a very brief answer. 1.29. What is the ratio of the Revenue generated (in %) in Bulgaria in 2005 to that in 2012?
Your answer should be very brief. 0.96. What is the ratio of the Revenue generated (in %) of Burkina Faso in 2005 to that in 2012?
Your answer should be very brief. 1.02. What is the ratio of the Revenue generated (in %) of Liberia in 2005 to that in 2012?
Offer a terse response. 1.24. What is the ratio of the Revenue generated (in %) of Sri Lanka in 2005 to that in 2012?
Ensure brevity in your answer.  1.2. What is the ratio of the Revenue generated (in %) of Bulgaria in 2006 to that in 2007?
Keep it short and to the point. 1. What is the ratio of the Revenue generated (in %) in Burkina Faso in 2006 to that in 2007?
Keep it short and to the point. 1.03. What is the ratio of the Revenue generated (in %) of Liberia in 2006 to that in 2007?
Ensure brevity in your answer.  1.32. What is the ratio of the Revenue generated (in %) in Sri Lanka in 2006 to that in 2007?
Make the answer very short. 1.06. What is the ratio of the Revenue generated (in %) in Bulgaria in 2006 to that in 2008?
Keep it short and to the point. 0.97. What is the ratio of the Revenue generated (in %) of Burkina Faso in 2006 to that in 2008?
Your answer should be compact. 0.89. What is the ratio of the Revenue generated (in %) in Liberia in 2006 to that in 2008?
Provide a succinct answer. 1.64. What is the ratio of the Revenue generated (in %) of Sri Lanka in 2006 to that in 2008?
Give a very brief answer. 1.15. What is the ratio of the Revenue generated (in %) of Bulgaria in 2006 to that in 2010?
Make the answer very short. 1. What is the ratio of the Revenue generated (in %) of Burkina Faso in 2006 to that in 2010?
Give a very brief answer. 0.95. What is the ratio of the Revenue generated (in %) of Liberia in 2006 to that in 2010?
Offer a terse response. 1.39. What is the ratio of the Revenue generated (in %) in Sri Lanka in 2006 to that in 2010?
Provide a short and direct response. 1.2. What is the ratio of the Revenue generated (in %) of Bulgaria in 2006 to that in 2011?
Offer a very short reply. 1.01. What is the ratio of the Revenue generated (in %) of Burkina Faso in 2006 to that in 2011?
Offer a very short reply. 0.98. What is the ratio of the Revenue generated (in %) of Liberia in 2006 to that in 2011?
Offer a very short reply. 1.62. What is the ratio of the Revenue generated (in %) of Sri Lanka in 2006 to that in 2011?
Offer a terse response. 1.19. What is the ratio of the Revenue generated (in %) of Bulgaria in 2006 to that in 2012?
Your response must be concise. 1.03. What is the ratio of the Revenue generated (in %) of Burkina Faso in 2006 to that in 2012?
Your answer should be compact. 0.93. What is the ratio of the Revenue generated (in %) in Liberia in 2006 to that in 2012?
Keep it short and to the point. 1.79. What is the ratio of the Revenue generated (in %) of Sri Lanka in 2006 to that in 2012?
Give a very brief answer. 1.11. What is the ratio of the Revenue generated (in %) in Bulgaria in 2007 to that in 2008?
Provide a short and direct response. 0.97. What is the ratio of the Revenue generated (in %) in Burkina Faso in 2007 to that in 2008?
Give a very brief answer. 0.86. What is the ratio of the Revenue generated (in %) in Liberia in 2007 to that in 2008?
Your answer should be very brief. 1.24. What is the ratio of the Revenue generated (in %) of Sri Lanka in 2007 to that in 2008?
Give a very brief answer. 1.08. What is the ratio of the Revenue generated (in %) of Burkina Faso in 2007 to that in 2010?
Offer a very short reply. 0.91. What is the ratio of the Revenue generated (in %) in Liberia in 2007 to that in 2010?
Your answer should be very brief. 1.06. What is the ratio of the Revenue generated (in %) of Sri Lanka in 2007 to that in 2010?
Provide a succinct answer. 1.13. What is the ratio of the Revenue generated (in %) of Bulgaria in 2007 to that in 2011?
Ensure brevity in your answer.  1.01. What is the ratio of the Revenue generated (in %) in Burkina Faso in 2007 to that in 2011?
Keep it short and to the point. 0.94. What is the ratio of the Revenue generated (in %) in Liberia in 2007 to that in 2011?
Ensure brevity in your answer.  1.23. What is the ratio of the Revenue generated (in %) of Sri Lanka in 2007 to that in 2011?
Provide a succinct answer. 1.12. What is the ratio of the Revenue generated (in %) in Bulgaria in 2007 to that in 2012?
Offer a very short reply. 1.03. What is the ratio of the Revenue generated (in %) of Burkina Faso in 2007 to that in 2012?
Your answer should be compact. 0.9. What is the ratio of the Revenue generated (in %) in Liberia in 2007 to that in 2012?
Your answer should be very brief. 1.35. What is the ratio of the Revenue generated (in %) of Sri Lanka in 2007 to that in 2012?
Give a very brief answer. 1.04. What is the ratio of the Revenue generated (in %) in Bulgaria in 2008 to that in 2010?
Your answer should be compact. 1.03. What is the ratio of the Revenue generated (in %) in Burkina Faso in 2008 to that in 2010?
Your answer should be compact. 1.07. What is the ratio of the Revenue generated (in %) in Liberia in 2008 to that in 2010?
Keep it short and to the point. 0.85. What is the ratio of the Revenue generated (in %) in Sri Lanka in 2008 to that in 2010?
Your response must be concise. 1.05. What is the ratio of the Revenue generated (in %) in Bulgaria in 2008 to that in 2011?
Keep it short and to the point. 1.04. What is the ratio of the Revenue generated (in %) of Burkina Faso in 2008 to that in 2011?
Your answer should be compact. 1.1. What is the ratio of the Revenue generated (in %) of Liberia in 2008 to that in 2011?
Provide a succinct answer. 0.99. What is the ratio of the Revenue generated (in %) of Sri Lanka in 2008 to that in 2011?
Your answer should be compact. 1.04. What is the ratio of the Revenue generated (in %) in Bulgaria in 2008 to that in 2012?
Your response must be concise. 1.06. What is the ratio of the Revenue generated (in %) in Burkina Faso in 2008 to that in 2012?
Provide a short and direct response. 1.06. What is the ratio of the Revenue generated (in %) in Liberia in 2008 to that in 2012?
Offer a terse response. 1.09. What is the ratio of the Revenue generated (in %) of Sri Lanka in 2008 to that in 2012?
Your response must be concise. 0.97. What is the ratio of the Revenue generated (in %) in Bulgaria in 2010 to that in 2011?
Keep it short and to the point. 1.01. What is the ratio of the Revenue generated (in %) in Burkina Faso in 2010 to that in 2011?
Provide a short and direct response. 1.03. What is the ratio of the Revenue generated (in %) in Liberia in 2010 to that in 2011?
Your answer should be compact. 1.16. What is the ratio of the Revenue generated (in %) in Bulgaria in 2010 to that in 2012?
Your response must be concise. 1.03. What is the ratio of the Revenue generated (in %) of Liberia in 2010 to that in 2012?
Your answer should be very brief. 1.28. What is the ratio of the Revenue generated (in %) of Sri Lanka in 2010 to that in 2012?
Give a very brief answer. 0.92. What is the ratio of the Revenue generated (in %) of Bulgaria in 2011 to that in 2012?
Provide a succinct answer. 1.02. What is the ratio of the Revenue generated (in %) of Burkina Faso in 2011 to that in 2012?
Your answer should be very brief. 0.96. What is the ratio of the Revenue generated (in %) in Liberia in 2011 to that in 2012?
Ensure brevity in your answer.  1.1. What is the ratio of the Revenue generated (in %) of Sri Lanka in 2011 to that in 2012?
Make the answer very short. 0.93. What is the difference between the highest and the second highest Revenue generated (in %) in Bulgaria?
Make the answer very short. 1.19. What is the difference between the highest and the second highest Revenue generated (in %) in Burkina Faso?
Provide a succinct answer. 1.36. What is the difference between the highest and the second highest Revenue generated (in %) of Liberia?
Your answer should be compact. 5.75. What is the difference between the highest and the second highest Revenue generated (in %) in Sri Lanka?
Keep it short and to the point. 4.15. What is the difference between the highest and the lowest Revenue generated (in %) of Bulgaria?
Your answer should be very brief. 4.33. What is the difference between the highest and the lowest Revenue generated (in %) in Burkina Faso?
Your answer should be compact. 5.57. What is the difference between the highest and the lowest Revenue generated (in %) in Liberia?
Ensure brevity in your answer.  10.45. What is the difference between the highest and the lowest Revenue generated (in %) of Sri Lanka?
Your answer should be compact. 12.68. 